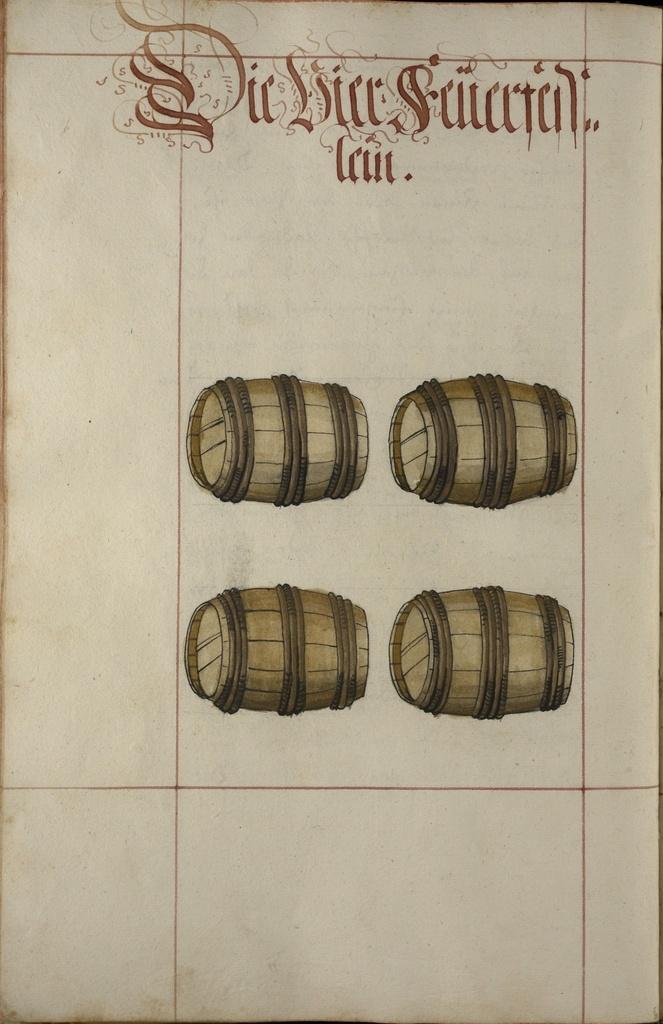Describe this image in one or two sentences. This is a picture of a paper. In the center of the picture there are paintings of drums. At the top there is text. 